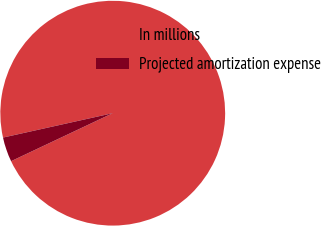Convert chart. <chart><loc_0><loc_0><loc_500><loc_500><pie_chart><fcel>In millions<fcel>Projected amortization expense<nl><fcel>96.46%<fcel>3.54%<nl></chart> 